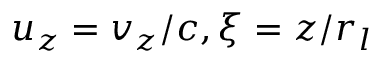Convert formula to latex. <formula><loc_0><loc_0><loc_500><loc_500>u _ { z } = v _ { z } / c , \xi = z / r _ { l }</formula> 